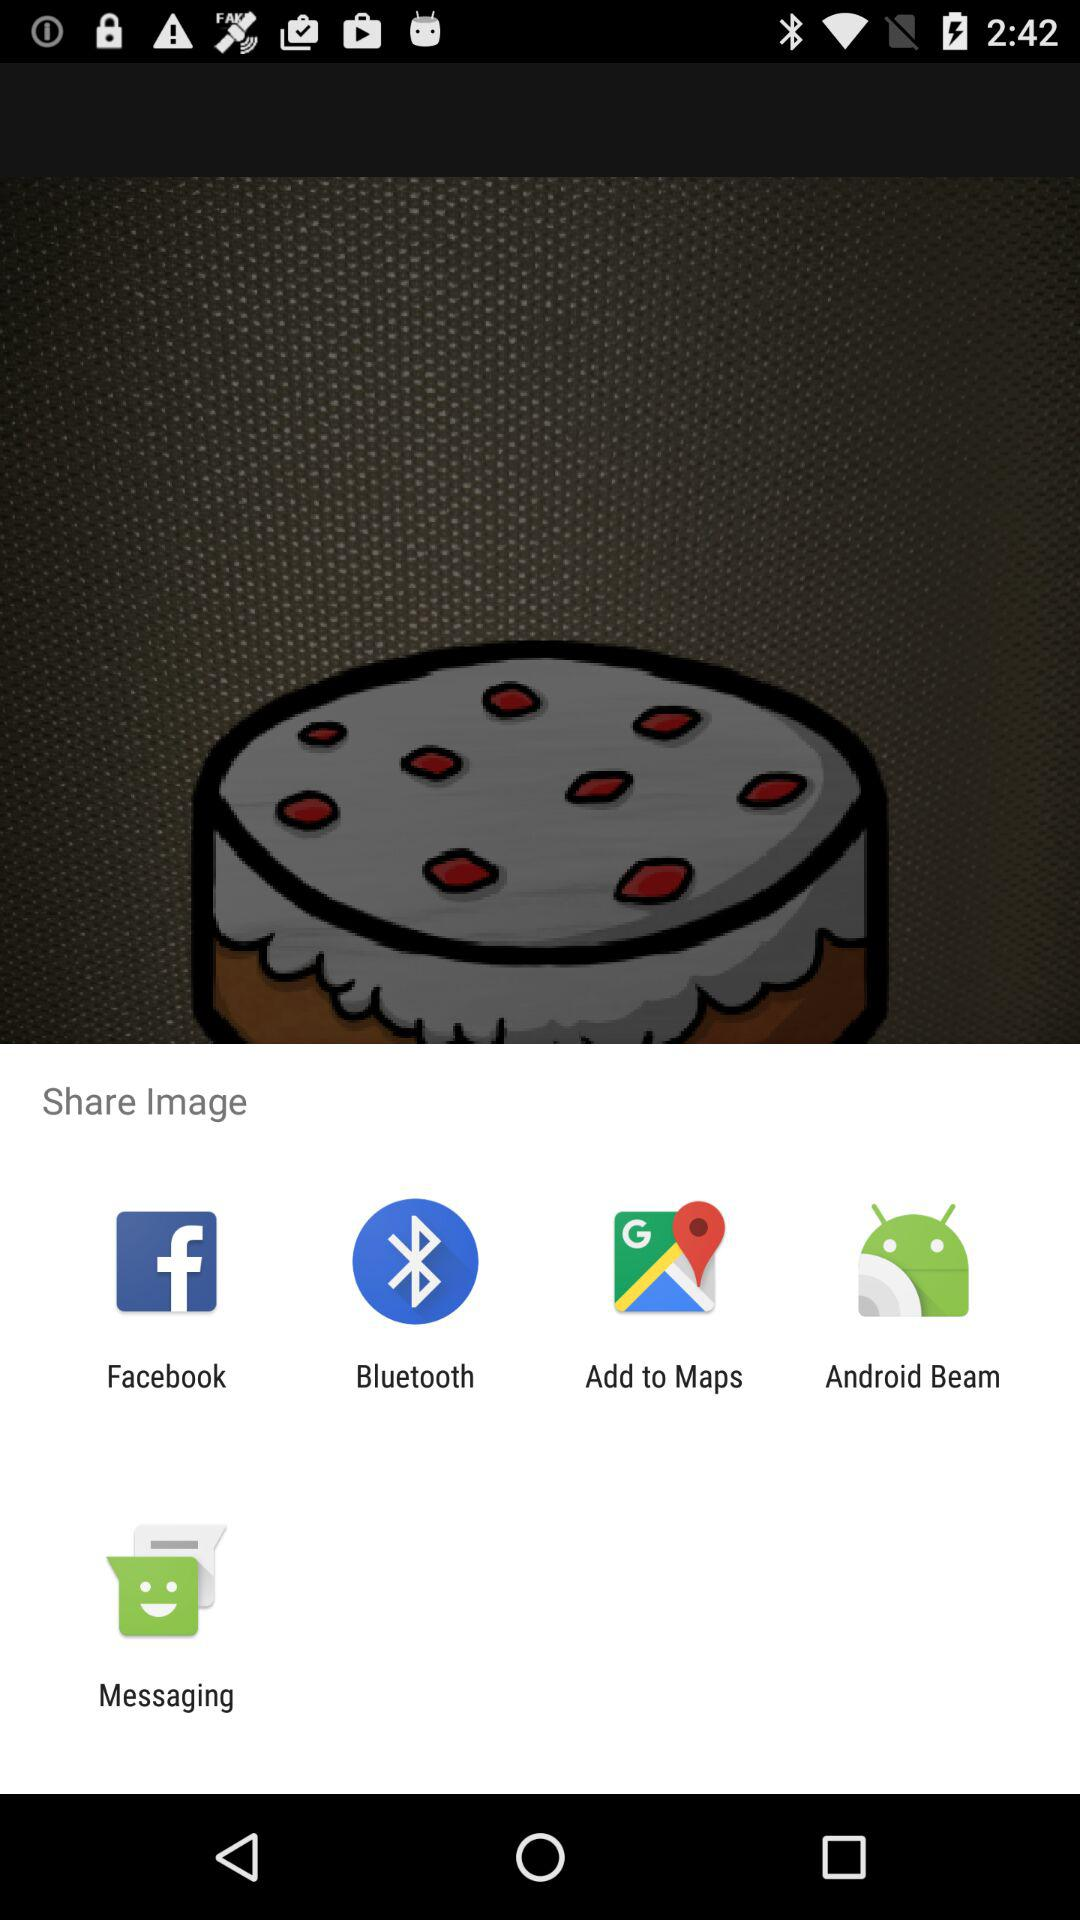What are the sharing options? The sharing options are "Facebook", "Bluetooth ", "Add to Maps", "Android Beam" and "Messaging". 